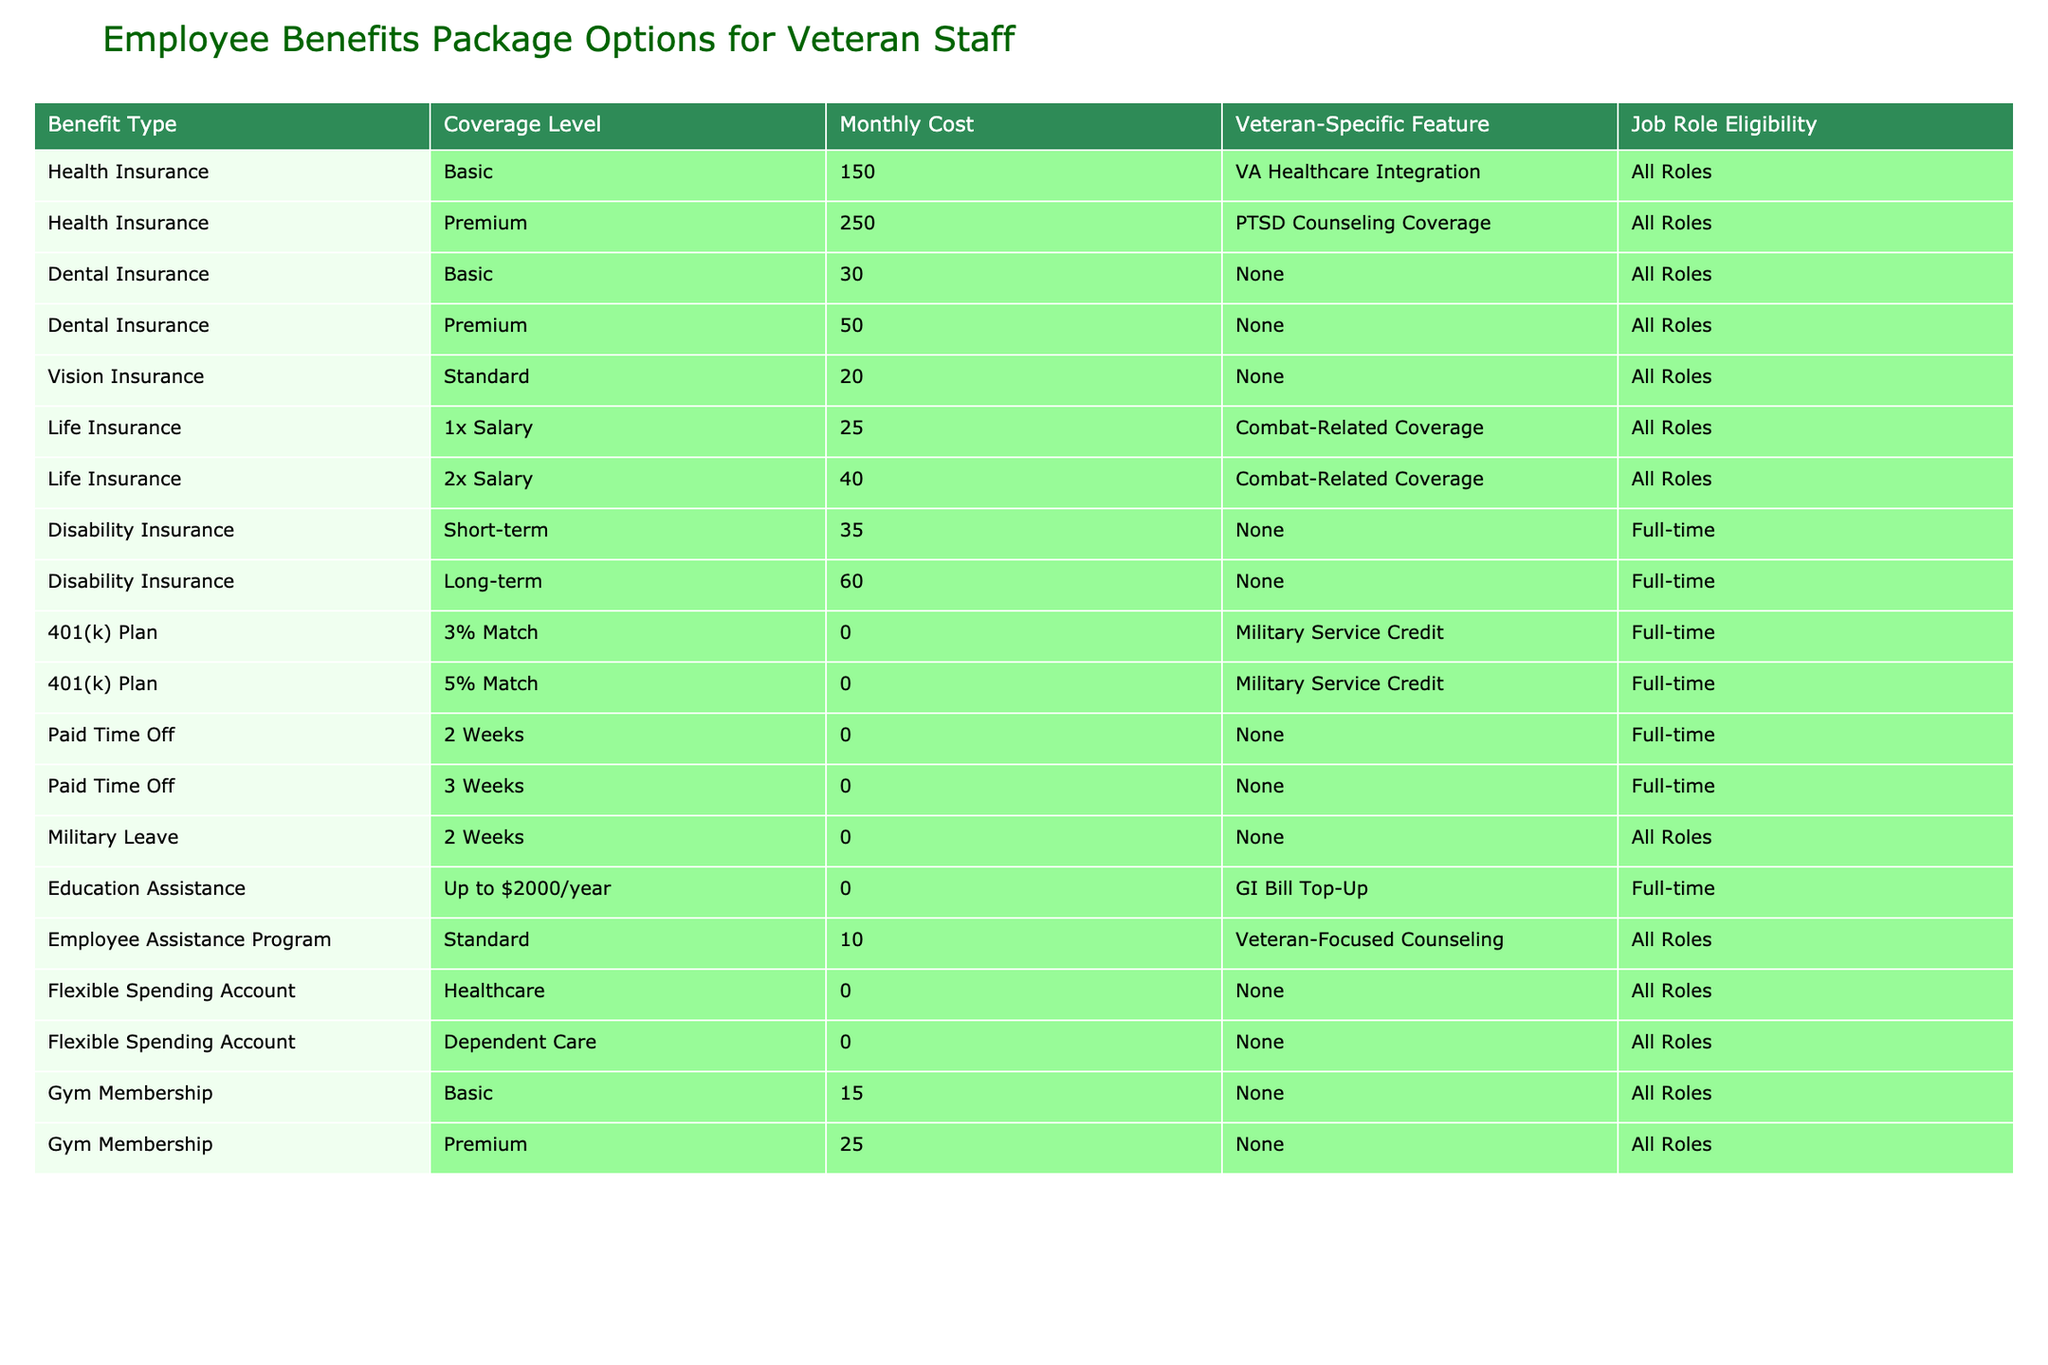What is the monthly cost of the premium health insurance option? The table lists various benefit types and their associated monthly costs. For health insurance, the premium coverage level is specifically mentioned, and the monthly cost is provided in the corresponding column. Thus, by finding the row for "Health Insurance" under "Premium," we see the monthly cost is 250.
Answer: 250 How many weeks of Paid Time Off is available for full-time employees? The table shows two options for Paid Time Off specifically for full-time employees: 2 weeks and 3 weeks. Since both options are listed, we can count them as two distinct choices available to full-time employees.
Answer: 2 options: 2 weeks and 3 weeks Is there a dental insurance option with a veteran-specific feature? The table shows two categories of dental insurance, both basic and premium. However, they do not include any veteran-specific features, as indicated in the corresponding column for both rows. Therefore, the answer to whether there is an option with a veteran-specific feature is no.
Answer: No What is the total monthly cost for having both basic dental insurance and basic vision insurance? To find this, we need to look at the monthly costs for both the basic dental insurance and the standard vision insurance in the table. The cost for basic dental insurance is 30, and for standard vision insurance, it's 20. Adding these together gives us 30 + 20 = 50.
Answer: 50 Which job roles are eligible for disability insurance? The table lists "Disability Insurance" with two types: short-term and long-term. Both types indicate eligibility specifically for full-time roles only, as shown in the "Job Role Eligibility" column. Therefore, the only roles eligible for disability insurance are full-time roles.
Answer: Full-time roles only What percentage of monthly costs is covered by the 5% match in the 401(k) plan? The 5% match in the 401(k) plan has a monthly cost of 0. Since the table shows a cost of 0, the match can be calculated against any salary amount, but here, we consider the relative cost as part of the total benefits. In terms of percentage, since a percentage of zero is still zero, we conclude that the 5% match does not contribute to any monthly costs.
Answer: 0% Are all roles eligible for the Employee Assistance Program? According to the table, the Employee Assistance Program is listed in the "Veteran-Specific Feature" column, and its job role eligibility is specified as "All Roles." This confirms that every job role has access to this program.
Answer: Yes How many total unique types of insurance benefits are offered? We look at the "Benefit Type" column and count the unique categories listed: Health Insurance, Dental Insurance, Vision Insurance, Life Insurance, and Disability Insurance. In total, there are five types of insurance benefits available, identified as unique types in the column.
Answer: 5 types How does the monthly cost of long-term disability insurance compare to the monthly cost of the premium health insurance option? The monthly cost for long-term disability insurance is given as 60. The premium health insurance cost is noted as 250. To compare, we see that 60 is less than 250. Therefore, the long-term disability insurance cost is lower than the premium health insurance.
Answer: Lower 